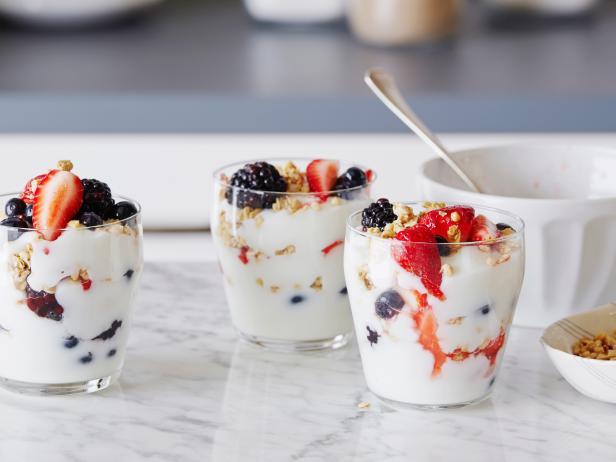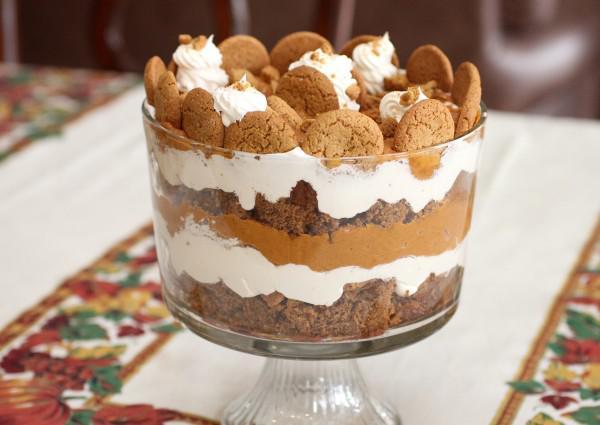The first image is the image on the left, the second image is the image on the right. Evaluate the accuracy of this statement regarding the images: "One image shows a single large trifle dessert in a footed serving bowl.". Is it true? Answer yes or no. Yes. 